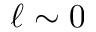<formula> <loc_0><loc_0><loc_500><loc_500>\ell \sim 0</formula> 